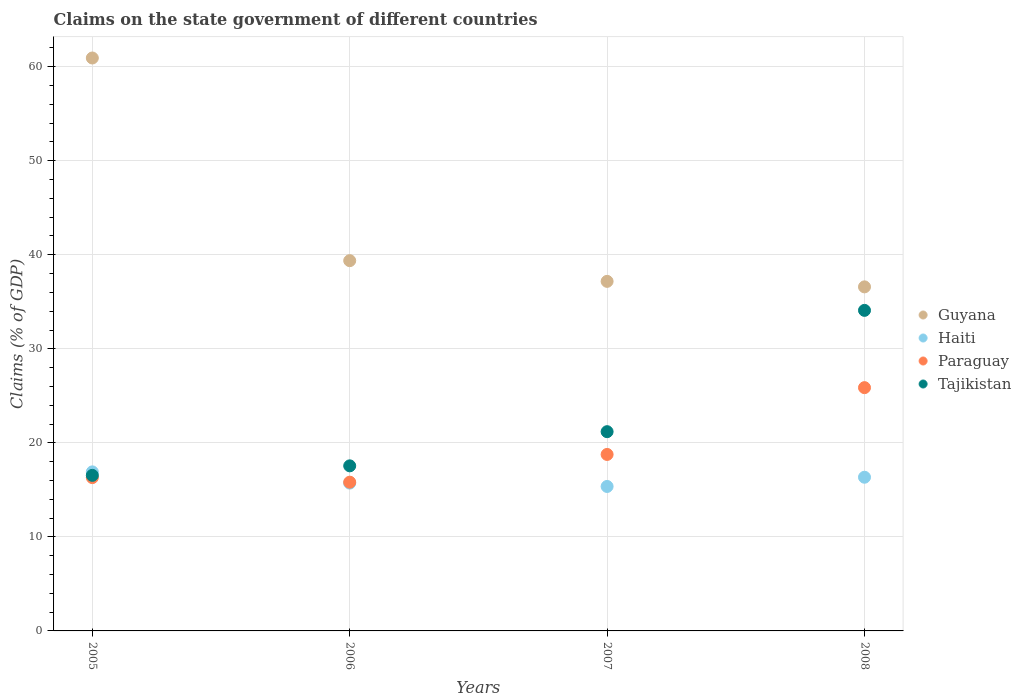How many different coloured dotlines are there?
Your response must be concise. 4. Is the number of dotlines equal to the number of legend labels?
Make the answer very short. Yes. What is the percentage of GDP claimed on the state government in Tajikistan in 2008?
Offer a terse response. 34.09. Across all years, what is the maximum percentage of GDP claimed on the state government in Tajikistan?
Your answer should be very brief. 34.09. Across all years, what is the minimum percentage of GDP claimed on the state government in Haiti?
Offer a very short reply. 15.36. In which year was the percentage of GDP claimed on the state government in Tajikistan maximum?
Your response must be concise. 2008. What is the total percentage of GDP claimed on the state government in Paraguay in the graph?
Offer a terse response. 76.76. What is the difference between the percentage of GDP claimed on the state government in Guyana in 2005 and that in 2006?
Keep it short and to the point. 21.55. What is the difference between the percentage of GDP claimed on the state government in Tajikistan in 2008 and the percentage of GDP claimed on the state government in Haiti in 2007?
Your answer should be compact. 18.73. What is the average percentage of GDP claimed on the state government in Paraguay per year?
Provide a succinct answer. 19.19. In the year 2008, what is the difference between the percentage of GDP claimed on the state government in Tajikistan and percentage of GDP claimed on the state government in Paraguay?
Ensure brevity in your answer.  8.22. What is the ratio of the percentage of GDP claimed on the state government in Guyana in 2006 to that in 2008?
Offer a very short reply. 1.08. Is the percentage of GDP claimed on the state government in Paraguay in 2005 less than that in 2008?
Provide a short and direct response. Yes. Is the difference between the percentage of GDP claimed on the state government in Tajikistan in 2006 and 2007 greater than the difference between the percentage of GDP claimed on the state government in Paraguay in 2006 and 2007?
Offer a very short reply. No. What is the difference between the highest and the second highest percentage of GDP claimed on the state government in Tajikistan?
Give a very brief answer. 12.9. What is the difference between the highest and the lowest percentage of GDP claimed on the state government in Tajikistan?
Provide a succinct answer. 17.55. Is the sum of the percentage of GDP claimed on the state government in Paraguay in 2005 and 2008 greater than the maximum percentage of GDP claimed on the state government in Tajikistan across all years?
Offer a terse response. Yes. Is it the case that in every year, the sum of the percentage of GDP claimed on the state government in Tajikistan and percentage of GDP claimed on the state government in Paraguay  is greater than the sum of percentage of GDP claimed on the state government in Haiti and percentage of GDP claimed on the state government in Guyana?
Give a very brief answer. No. Does the percentage of GDP claimed on the state government in Tajikistan monotonically increase over the years?
Your response must be concise. Yes. Is the percentage of GDP claimed on the state government in Tajikistan strictly greater than the percentage of GDP claimed on the state government in Paraguay over the years?
Your response must be concise. Yes. Is the percentage of GDP claimed on the state government in Paraguay strictly less than the percentage of GDP claimed on the state government in Guyana over the years?
Your answer should be very brief. Yes. How many years are there in the graph?
Provide a succinct answer. 4. Are the values on the major ticks of Y-axis written in scientific E-notation?
Provide a succinct answer. No. How many legend labels are there?
Your answer should be very brief. 4. What is the title of the graph?
Your answer should be very brief. Claims on the state government of different countries. What is the label or title of the X-axis?
Keep it short and to the point. Years. What is the label or title of the Y-axis?
Give a very brief answer. Claims (% of GDP). What is the Claims (% of GDP) in Guyana in 2005?
Provide a short and direct response. 60.93. What is the Claims (% of GDP) in Haiti in 2005?
Your answer should be very brief. 16.91. What is the Claims (% of GDP) of Paraguay in 2005?
Your response must be concise. 16.31. What is the Claims (% of GDP) of Tajikistan in 2005?
Your response must be concise. 16.54. What is the Claims (% of GDP) in Guyana in 2006?
Your response must be concise. 39.38. What is the Claims (% of GDP) in Haiti in 2006?
Your answer should be compact. 15.72. What is the Claims (% of GDP) in Paraguay in 2006?
Make the answer very short. 15.82. What is the Claims (% of GDP) in Tajikistan in 2006?
Give a very brief answer. 17.56. What is the Claims (% of GDP) in Guyana in 2007?
Your answer should be very brief. 37.18. What is the Claims (% of GDP) in Haiti in 2007?
Offer a terse response. 15.36. What is the Claims (% of GDP) in Paraguay in 2007?
Ensure brevity in your answer.  18.77. What is the Claims (% of GDP) of Tajikistan in 2007?
Your answer should be very brief. 21.19. What is the Claims (% of GDP) in Guyana in 2008?
Make the answer very short. 36.59. What is the Claims (% of GDP) in Haiti in 2008?
Keep it short and to the point. 16.34. What is the Claims (% of GDP) in Paraguay in 2008?
Your answer should be compact. 25.87. What is the Claims (% of GDP) of Tajikistan in 2008?
Provide a short and direct response. 34.09. Across all years, what is the maximum Claims (% of GDP) in Guyana?
Make the answer very short. 60.93. Across all years, what is the maximum Claims (% of GDP) of Haiti?
Provide a succinct answer. 16.91. Across all years, what is the maximum Claims (% of GDP) in Paraguay?
Offer a very short reply. 25.87. Across all years, what is the maximum Claims (% of GDP) in Tajikistan?
Your answer should be compact. 34.09. Across all years, what is the minimum Claims (% of GDP) in Guyana?
Provide a short and direct response. 36.59. Across all years, what is the minimum Claims (% of GDP) in Haiti?
Offer a very short reply. 15.36. Across all years, what is the minimum Claims (% of GDP) of Paraguay?
Offer a very short reply. 15.82. Across all years, what is the minimum Claims (% of GDP) of Tajikistan?
Offer a terse response. 16.54. What is the total Claims (% of GDP) in Guyana in the graph?
Your answer should be compact. 174.07. What is the total Claims (% of GDP) of Haiti in the graph?
Provide a short and direct response. 64.34. What is the total Claims (% of GDP) of Paraguay in the graph?
Ensure brevity in your answer.  76.76. What is the total Claims (% of GDP) of Tajikistan in the graph?
Your response must be concise. 89.38. What is the difference between the Claims (% of GDP) of Guyana in 2005 and that in 2006?
Offer a very short reply. 21.55. What is the difference between the Claims (% of GDP) of Haiti in 2005 and that in 2006?
Make the answer very short. 1.19. What is the difference between the Claims (% of GDP) of Paraguay in 2005 and that in 2006?
Your answer should be very brief. 0.49. What is the difference between the Claims (% of GDP) of Tajikistan in 2005 and that in 2006?
Provide a short and direct response. -1.01. What is the difference between the Claims (% of GDP) of Guyana in 2005 and that in 2007?
Your answer should be compact. 23.75. What is the difference between the Claims (% of GDP) in Haiti in 2005 and that in 2007?
Your answer should be very brief. 1.55. What is the difference between the Claims (% of GDP) of Paraguay in 2005 and that in 2007?
Provide a short and direct response. -2.46. What is the difference between the Claims (% of GDP) in Tajikistan in 2005 and that in 2007?
Make the answer very short. -4.65. What is the difference between the Claims (% of GDP) in Guyana in 2005 and that in 2008?
Give a very brief answer. 24.34. What is the difference between the Claims (% of GDP) in Haiti in 2005 and that in 2008?
Provide a short and direct response. 0.57. What is the difference between the Claims (% of GDP) of Paraguay in 2005 and that in 2008?
Your answer should be very brief. -9.57. What is the difference between the Claims (% of GDP) of Tajikistan in 2005 and that in 2008?
Your answer should be compact. -17.55. What is the difference between the Claims (% of GDP) of Guyana in 2006 and that in 2007?
Ensure brevity in your answer.  2.2. What is the difference between the Claims (% of GDP) of Haiti in 2006 and that in 2007?
Provide a succinct answer. 0.36. What is the difference between the Claims (% of GDP) in Paraguay in 2006 and that in 2007?
Your answer should be very brief. -2.95. What is the difference between the Claims (% of GDP) of Tajikistan in 2006 and that in 2007?
Provide a succinct answer. -3.63. What is the difference between the Claims (% of GDP) in Guyana in 2006 and that in 2008?
Offer a terse response. 2.79. What is the difference between the Claims (% of GDP) in Haiti in 2006 and that in 2008?
Offer a very short reply. -0.62. What is the difference between the Claims (% of GDP) of Paraguay in 2006 and that in 2008?
Offer a terse response. -10.05. What is the difference between the Claims (% of GDP) in Tajikistan in 2006 and that in 2008?
Provide a succinct answer. -16.53. What is the difference between the Claims (% of GDP) in Guyana in 2007 and that in 2008?
Give a very brief answer. 0.59. What is the difference between the Claims (% of GDP) in Haiti in 2007 and that in 2008?
Make the answer very short. -0.98. What is the difference between the Claims (% of GDP) of Paraguay in 2007 and that in 2008?
Give a very brief answer. -7.1. What is the difference between the Claims (% of GDP) of Tajikistan in 2007 and that in 2008?
Ensure brevity in your answer.  -12.9. What is the difference between the Claims (% of GDP) in Guyana in 2005 and the Claims (% of GDP) in Haiti in 2006?
Offer a terse response. 45.21. What is the difference between the Claims (% of GDP) in Guyana in 2005 and the Claims (% of GDP) in Paraguay in 2006?
Offer a very short reply. 45.11. What is the difference between the Claims (% of GDP) of Guyana in 2005 and the Claims (% of GDP) of Tajikistan in 2006?
Your response must be concise. 43.37. What is the difference between the Claims (% of GDP) in Haiti in 2005 and the Claims (% of GDP) in Paraguay in 2006?
Your answer should be compact. 1.09. What is the difference between the Claims (% of GDP) of Haiti in 2005 and the Claims (% of GDP) of Tajikistan in 2006?
Your response must be concise. -0.64. What is the difference between the Claims (% of GDP) of Paraguay in 2005 and the Claims (% of GDP) of Tajikistan in 2006?
Provide a succinct answer. -1.25. What is the difference between the Claims (% of GDP) of Guyana in 2005 and the Claims (% of GDP) of Haiti in 2007?
Give a very brief answer. 45.57. What is the difference between the Claims (% of GDP) of Guyana in 2005 and the Claims (% of GDP) of Paraguay in 2007?
Offer a very short reply. 42.16. What is the difference between the Claims (% of GDP) in Guyana in 2005 and the Claims (% of GDP) in Tajikistan in 2007?
Keep it short and to the point. 39.74. What is the difference between the Claims (% of GDP) in Haiti in 2005 and the Claims (% of GDP) in Paraguay in 2007?
Your answer should be very brief. -1.85. What is the difference between the Claims (% of GDP) of Haiti in 2005 and the Claims (% of GDP) of Tajikistan in 2007?
Your answer should be very brief. -4.28. What is the difference between the Claims (% of GDP) of Paraguay in 2005 and the Claims (% of GDP) of Tajikistan in 2007?
Your answer should be very brief. -4.88. What is the difference between the Claims (% of GDP) in Guyana in 2005 and the Claims (% of GDP) in Haiti in 2008?
Offer a very short reply. 44.59. What is the difference between the Claims (% of GDP) of Guyana in 2005 and the Claims (% of GDP) of Paraguay in 2008?
Your answer should be very brief. 35.06. What is the difference between the Claims (% of GDP) in Guyana in 2005 and the Claims (% of GDP) in Tajikistan in 2008?
Give a very brief answer. 26.84. What is the difference between the Claims (% of GDP) in Haiti in 2005 and the Claims (% of GDP) in Paraguay in 2008?
Your answer should be very brief. -8.96. What is the difference between the Claims (% of GDP) of Haiti in 2005 and the Claims (% of GDP) of Tajikistan in 2008?
Your response must be concise. -17.18. What is the difference between the Claims (% of GDP) of Paraguay in 2005 and the Claims (% of GDP) of Tajikistan in 2008?
Ensure brevity in your answer.  -17.78. What is the difference between the Claims (% of GDP) in Guyana in 2006 and the Claims (% of GDP) in Haiti in 2007?
Your response must be concise. 24.01. What is the difference between the Claims (% of GDP) in Guyana in 2006 and the Claims (% of GDP) in Paraguay in 2007?
Give a very brief answer. 20.61. What is the difference between the Claims (% of GDP) in Guyana in 2006 and the Claims (% of GDP) in Tajikistan in 2007?
Provide a short and direct response. 18.19. What is the difference between the Claims (% of GDP) of Haiti in 2006 and the Claims (% of GDP) of Paraguay in 2007?
Provide a short and direct response. -3.05. What is the difference between the Claims (% of GDP) in Haiti in 2006 and the Claims (% of GDP) in Tajikistan in 2007?
Offer a very short reply. -5.47. What is the difference between the Claims (% of GDP) of Paraguay in 2006 and the Claims (% of GDP) of Tajikistan in 2007?
Offer a terse response. -5.37. What is the difference between the Claims (% of GDP) of Guyana in 2006 and the Claims (% of GDP) of Haiti in 2008?
Provide a succinct answer. 23.03. What is the difference between the Claims (% of GDP) of Guyana in 2006 and the Claims (% of GDP) of Paraguay in 2008?
Provide a short and direct response. 13.5. What is the difference between the Claims (% of GDP) in Guyana in 2006 and the Claims (% of GDP) in Tajikistan in 2008?
Make the answer very short. 5.29. What is the difference between the Claims (% of GDP) in Haiti in 2006 and the Claims (% of GDP) in Paraguay in 2008?
Ensure brevity in your answer.  -10.15. What is the difference between the Claims (% of GDP) of Haiti in 2006 and the Claims (% of GDP) of Tajikistan in 2008?
Offer a terse response. -18.37. What is the difference between the Claims (% of GDP) in Paraguay in 2006 and the Claims (% of GDP) in Tajikistan in 2008?
Offer a very short reply. -18.27. What is the difference between the Claims (% of GDP) in Guyana in 2007 and the Claims (% of GDP) in Haiti in 2008?
Ensure brevity in your answer.  20.83. What is the difference between the Claims (% of GDP) in Guyana in 2007 and the Claims (% of GDP) in Paraguay in 2008?
Keep it short and to the point. 11.3. What is the difference between the Claims (% of GDP) of Guyana in 2007 and the Claims (% of GDP) of Tajikistan in 2008?
Ensure brevity in your answer.  3.09. What is the difference between the Claims (% of GDP) of Haiti in 2007 and the Claims (% of GDP) of Paraguay in 2008?
Your answer should be compact. -10.51. What is the difference between the Claims (% of GDP) in Haiti in 2007 and the Claims (% of GDP) in Tajikistan in 2008?
Keep it short and to the point. -18.73. What is the difference between the Claims (% of GDP) of Paraguay in 2007 and the Claims (% of GDP) of Tajikistan in 2008?
Provide a succinct answer. -15.32. What is the average Claims (% of GDP) of Guyana per year?
Your answer should be very brief. 43.52. What is the average Claims (% of GDP) in Haiti per year?
Keep it short and to the point. 16.09. What is the average Claims (% of GDP) in Paraguay per year?
Offer a terse response. 19.19. What is the average Claims (% of GDP) in Tajikistan per year?
Give a very brief answer. 22.34. In the year 2005, what is the difference between the Claims (% of GDP) in Guyana and Claims (% of GDP) in Haiti?
Provide a succinct answer. 44.02. In the year 2005, what is the difference between the Claims (% of GDP) in Guyana and Claims (% of GDP) in Paraguay?
Make the answer very short. 44.62. In the year 2005, what is the difference between the Claims (% of GDP) in Guyana and Claims (% of GDP) in Tajikistan?
Offer a terse response. 44.39. In the year 2005, what is the difference between the Claims (% of GDP) of Haiti and Claims (% of GDP) of Paraguay?
Give a very brief answer. 0.61. In the year 2005, what is the difference between the Claims (% of GDP) of Haiti and Claims (% of GDP) of Tajikistan?
Your answer should be very brief. 0.37. In the year 2005, what is the difference between the Claims (% of GDP) in Paraguay and Claims (% of GDP) in Tajikistan?
Your answer should be very brief. -0.24. In the year 2006, what is the difference between the Claims (% of GDP) of Guyana and Claims (% of GDP) of Haiti?
Offer a terse response. 23.66. In the year 2006, what is the difference between the Claims (% of GDP) of Guyana and Claims (% of GDP) of Paraguay?
Ensure brevity in your answer.  23.56. In the year 2006, what is the difference between the Claims (% of GDP) in Guyana and Claims (% of GDP) in Tajikistan?
Your answer should be compact. 21.82. In the year 2006, what is the difference between the Claims (% of GDP) of Haiti and Claims (% of GDP) of Paraguay?
Provide a short and direct response. -0.1. In the year 2006, what is the difference between the Claims (% of GDP) in Haiti and Claims (% of GDP) in Tajikistan?
Give a very brief answer. -1.84. In the year 2006, what is the difference between the Claims (% of GDP) in Paraguay and Claims (% of GDP) in Tajikistan?
Ensure brevity in your answer.  -1.74. In the year 2007, what is the difference between the Claims (% of GDP) in Guyana and Claims (% of GDP) in Haiti?
Make the answer very short. 21.81. In the year 2007, what is the difference between the Claims (% of GDP) in Guyana and Claims (% of GDP) in Paraguay?
Your response must be concise. 18.41. In the year 2007, what is the difference between the Claims (% of GDP) of Guyana and Claims (% of GDP) of Tajikistan?
Keep it short and to the point. 15.99. In the year 2007, what is the difference between the Claims (% of GDP) of Haiti and Claims (% of GDP) of Paraguay?
Your answer should be compact. -3.4. In the year 2007, what is the difference between the Claims (% of GDP) in Haiti and Claims (% of GDP) in Tajikistan?
Your answer should be very brief. -5.83. In the year 2007, what is the difference between the Claims (% of GDP) of Paraguay and Claims (% of GDP) of Tajikistan?
Provide a succinct answer. -2.42. In the year 2008, what is the difference between the Claims (% of GDP) of Guyana and Claims (% of GDP) of Haiti?
Your answer should be compact. 20.25. In the year 2008, what is the difference between the Claims (% of GDP) of Guyana and Claims (% of GDP) of Paraguay?
Your answer should be compact. 10.72. In the year 2008, what is the difference between the Claims (% of GDP) in Haiti and Claims (% of GDP) in Paraguay?
Give a very brief answer. -9.53. In the year 2008, what is the difference between the Claims (% of GDP) in Haiti and Claims (% of GDP) in Tajikistan?
Your answer should be compact. -17.75. In the year 2008, what is the difference between the Claims (% of GDP) of Paraguay and Claims (% of GDP) of Tajikistan?
Keep it short and to the point. -8.22. What is the ratio of the Claims (% of GDP) of Guyana in 2005 to that in 2006?
Provide a succinct answer. 1.55. What is the ratio of the Claims (% of GDP) of Haiti in 2005 to that in 2006?
Offer a terse response. 1.08. What is the ratio of the Claims (% of GDP) of Paraguay in 2005 to that in 2006?
Make the answer very short. 1.03. What is the ratio of the Claims (% of GDP) in Tajikistan in 2005 to that in 2006?
Give a very brief answer. 0.94. What is the ratio of the Claims (% of GDP) of Guyana in 2005 to that in 2007?
Give a very brief answer. 1.64. What is the ratio of the Claims (% of GDP) in Haiti in 2005 to that in 2007?
Ensure brevity in your answer.  1.1. What is the ratio of the Claims (% of GDP) of Paraguay in 2005 to that in 2007?
Provide a short and direct response. 0.87. What is the ratio of the Claims (% of GDP) of Tajikistan in 2005 to that in 2007?
Offer a terse response. 0.78. What is the ratio of the Claims (% of GDP) of Guyana in 2005 to that in 2008?
Offer a very short reply. 1.67. What is the ratio of the Claims (% of GDP) of Haiti in 2005 to that in 2008?
Offer a very short reply. 1.03. What is the ratio of the Claims (% of GDP) of Paraguay in 2005 to that in 2008?
Keep it short and to the point. 0.63. What is the ratio of the Claims (% of GDP) of Tajikistan in 2005 to that in 2008?
Your answer should be compact. 0.49. What is the ratio of the Claims (% of GDP) of Guyana in 2006 to that in 2007?
Offer a very short reply. 1.06. What is the ratio of the Claims (% of GDP) in Haiti in 2006 to that in 2007?
Your response must be concise. 1.02. What is the ratio of the Claims (% of GDP) of Paraguay in 2006 to that in 2007?
Your response must be concise. 0.84. What is the ratio of the Claims (% of GDP) of Tajikistan in 2006 to that in 2007?
Your response must be concise. 0.83. What is the ratio of the Claims (% of GDP) of Guyana in 2006 to that in 2008?
Provide a short and direct response. 1.08. What is the ratio of the Claims (% of GDP) of Haiti in 2006 to that in 2008?
Your answer should be very brief. 0.96. What is the ratio of the Claims (% of GDP) of Paraguay in 2006 to that in 2008?
Offer a very short reply. 0.61. What is the ratio of the Claims (% of GDP) of Tajikistan in 2006 to that in 2008?
Make the answer very short. 0.52. What is the ratio of the Claims (% of GDP) of Guyana in 2007 to that in 2008?
Keep it short and to the point. 1.02. What is the ratio of the Claims (% of GDP) in Haiti in 2007 to that in 2008?
Your answer should be very brief. 0.94. What is the ratio of the Claims (% of GDP) of Paraguay in 2007 to that in 2008?
Give a very brief answer. 0.73. What is the ratio of the Claims (% of GDP) of Tajikistan in 2007 to that in 2008?
Your response must be concise. 0.62. What is the difference between the highest and the second highest Claims (% of GDP) of Guyana?
Make the answer very short. 21.55. What is the difference between the highest and the second highest Claims (% of GDP) in Haiti?
Give a very brief answer. 0.57. What is the difference between the highest and the second highest Claims (% of GDP) of Paraguay?
Keep it short and to the point. 7.1. What is the difference between the highest and the lowest Claims (% of GDP) in Guyana?
Provide a succinct answer. 24.34. What is the difference between the highest and the lowest Claims (% of GDP) of Haiti?
Keep it short and to the point. 1.55. What is the difference between the highest and the lowest Claims (% of GDP) in Paraguay?
Your response must be concise. 10.05. What is the difference between the highest and the lowest Claims (% of GDP) in Tajikistan?
Provide a short and direct response. 17.55. 